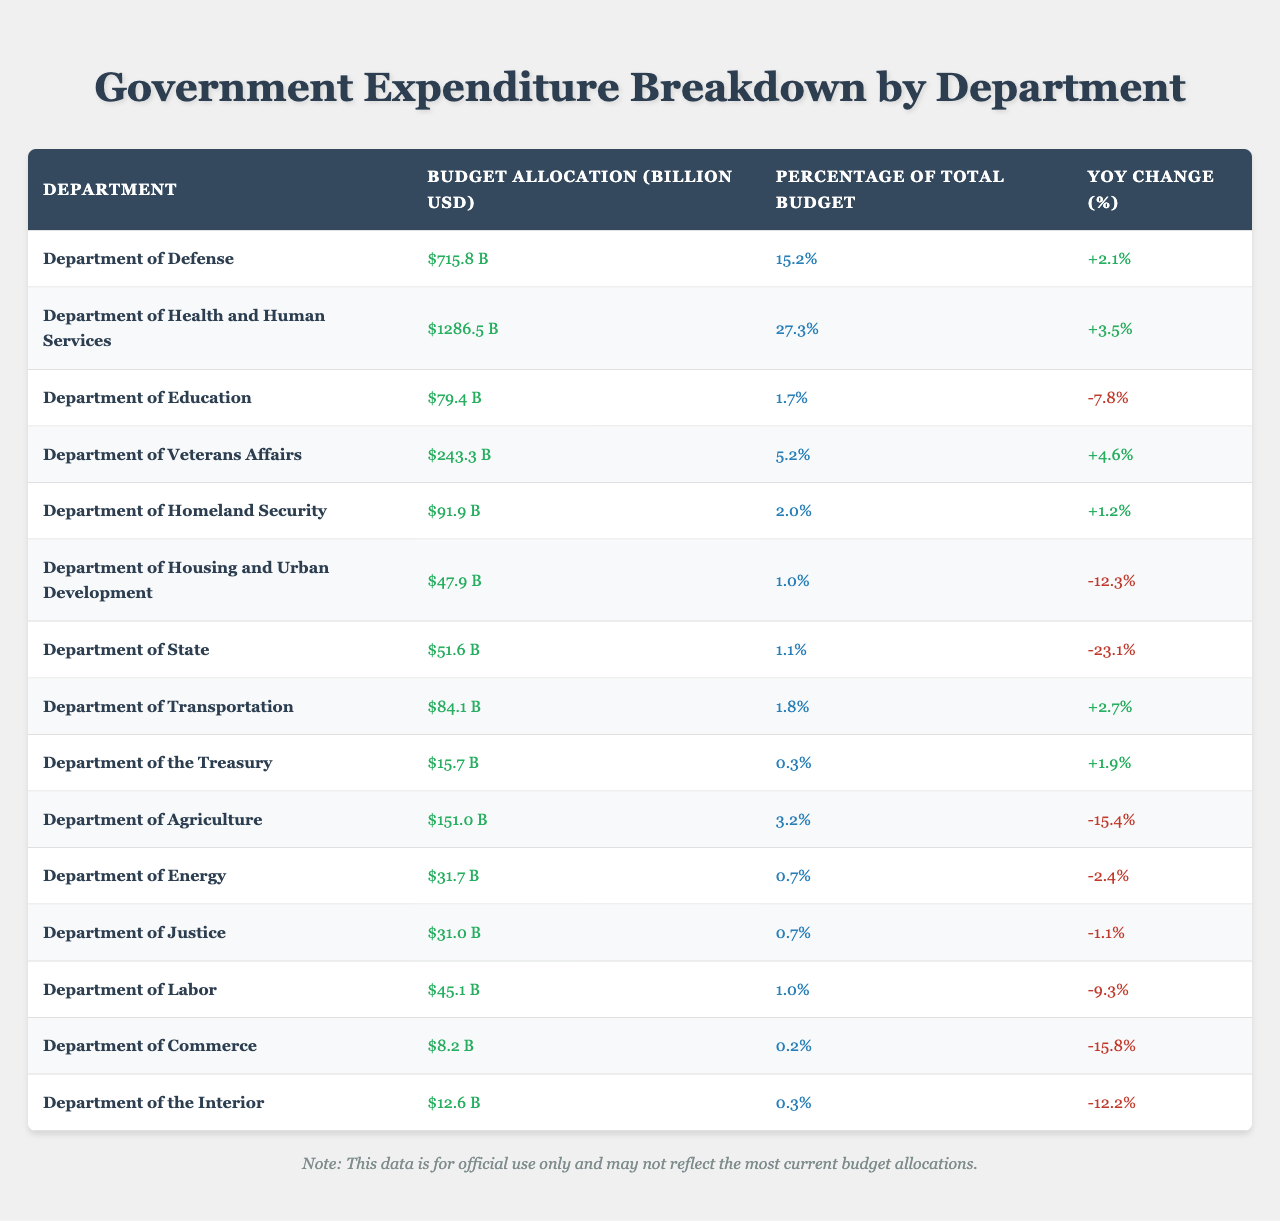What is the budget allocation for the Department of Health and Human Services? The table lists the budget allocation for each department, showing the Department of Health and Human Services with a budget of 1286.5 billion USD.
Answer: 1286.5 billion USD Which department has the highest percentage of the total budget? The table displays the percentage of the total budget for each department. The Department of Health and Human Services has the highest percentage at 27.3%.
Answer: 27.3% What is the YoY change (%) for the Department of Education? The table shows the Year over Year (YoY) change for each department, indicating that the Department of Education has a change of -7.8%.
Answer: -7.8% How much more does the Department of Defense receive compared to the Department of the Interior? By subtracting the budget for the Department of the Interior (12.6 billion USD) from the Department of Defense (715.8 billion USD), we find that the difference is 715.8 - 12.6 = 703.2 billion USD.
Answer: 703.2 billion USD What is the combined budget allocation for the Departments of Labor, Commerce, and Housing and Urban Development? The budget for these departments is listed as 45.1 billion USD (Labor), 8.2 billion USD (Commerce), and 47.9 billion USD (Housing and Urban Development). Summing these values gives 45.1 + 8.2 + 47.9 = 101.2 billion USD.
Answer: 101.2 billion USD Is the YoY change for the Department of Agriculture positive or negative? Looking at the table, the YoY change for the Department of Agriculture is -15.4%, which is a negative value.
Answer: Negative Which department saw the largest decrease in budget allocation compared to the previous year? The table shows the YoY change for each department. The Department of State experienced the largest decrease at -23.1%.
Answer: Department of State What is the average budget allocation for all departments listed in the table? To find the average, we sum all the budget allocations: 715.8 + 1286.5 + 79.4 + 243.3 + 91.9 + 47.9 + 51.6 + 84.1 + 15.7 + 151.0 + 31.7 + 31.0 + 45.1 + 8.2 + 12.6 = 2531.8 billion USD. There are 15 departments, so the average is 2531.8 / 15 = 168.79 billion USD.
Answer: 168.79 billion USD How many departments have a budget allocation of less than 100 billion USD? From the table, we can count the departments with budget allocations less than 100 billion USD: Education (79.4), Homeland Security (91.9), Housing and Urban Development (47.9), State (51.6), Treasury (15.7), Agriculture (151.0), Energy (31.7), Justice (31.0), Labor (45.1), Commerce (8.2), and the Interior (12.6). This results in a total of 10 departments.
Answer: 10 departments 